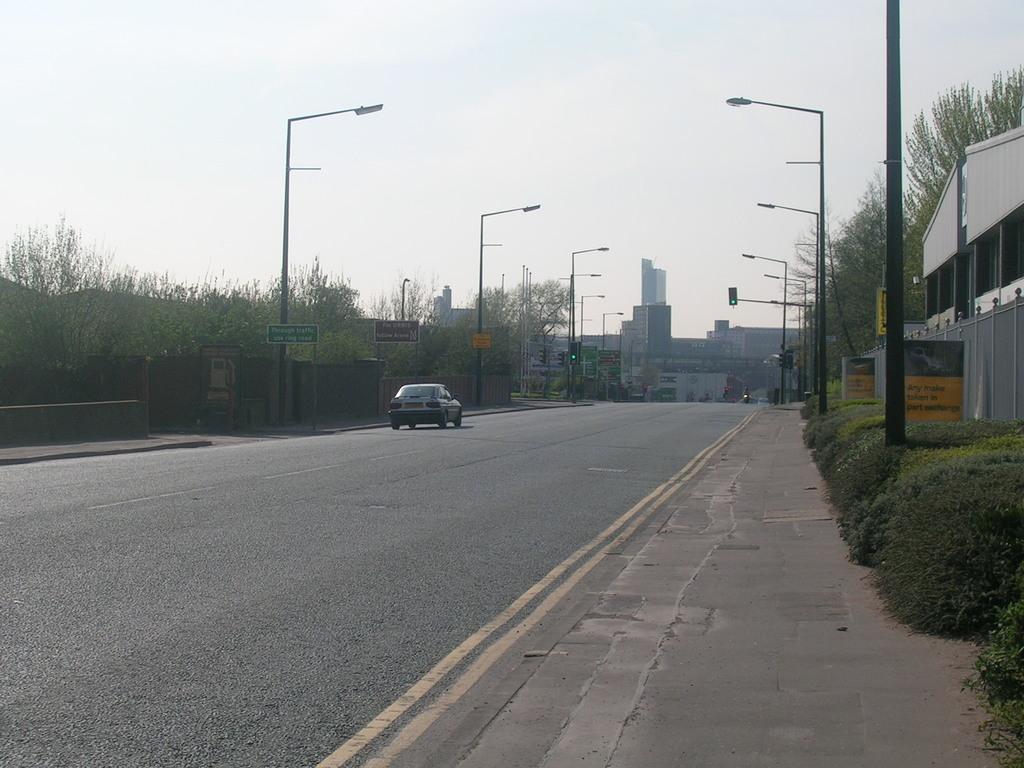In one or two sentences, can you explain what this image depicts? In this image we can see a car on the road. On the left side of the image we can see street lights, wall, footpath and trees. On the right side of the image we can see footpath, plants, building, trees and street lights. In the background there are buildings and sky. 